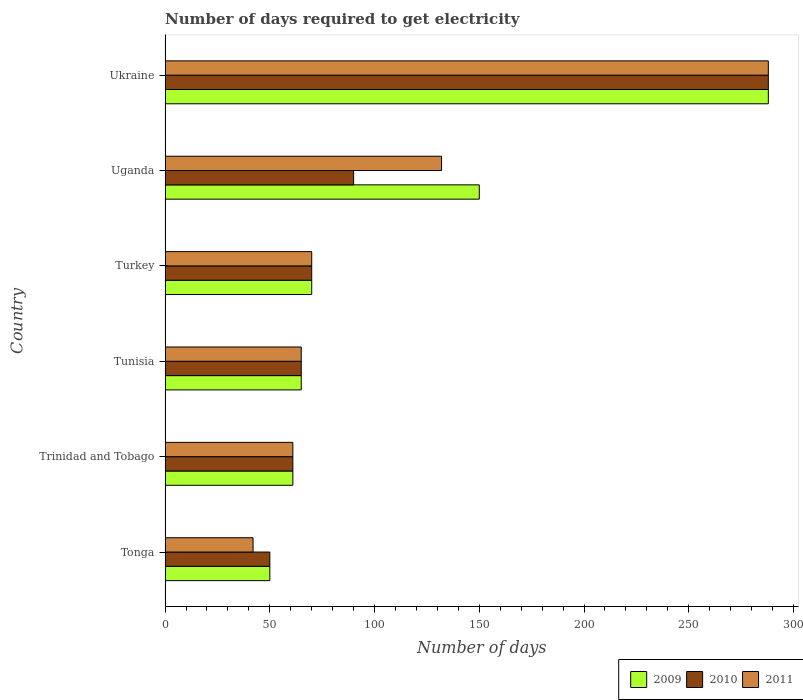How many different coloured bars are there?
Keep it short and to the point. 3. How many groups of bars are there?
Offer a terse response. 6. Are the number of bars per tick equal to the number of legend labels?
Keep it short and to the point. Yes. How many bars are there on the 3rd tick from the bottom?
Ensure brevity in your answer.  3. In how many cases, is the number of bars for a given country not equal to the number of legend labels?
Your answer should be very brief. 0. Across all countries, what is the maximum number of days required to get electricity in in 2010?
Provide a short and direct response. 288. In which country was the number of days required to get electricity in in 2009 maximum?
Offer a very short reply. Ukraine. In which country was the number of days required to get electricity in in 2010 minimum?
Offer a terse response. Tonga. What is the total number of days required to get electricity in in 2011 in the graph?
Offer a very short reply. 658. What is the difference between the number of days required to get electricity in in 2010 in Tonga and that in Trinidad and Tobago?
Your answer should be compact. -11. What is the difference between the number of days required to get electricity in in 2010 in Tunisia and the number of days required to get electricity in in 2011 in Ukraine?
Give a very brief answer. -223. What is the average number of days required to get electricity in in 2011 per country?
Provide a succinct answer. 109.67. What is the difference between the number of days required to get electricity in in 2009 and number of days required to get electricity in in 2010 in Tunisia?
Offer a very short reply. 0. What is the ratio of the number of days required to get electricity in in 2009 in Tunisia to that in Ukraine?
Offer a terse response. 0.23. Is the number of days required to get electricity in in 2011 in Tonga less than that in Trinidad and Tobago?
Offer a very short reply. Yes. Is the difference between the number of days required to get electricity in in 2009 in Trinidad and Tobago and Ukraine greater than the difference between the number of days required to get electricity in in 2010 in Trinidad and Tobago and Ukraine?
Your response must be concise. No. What is the difference between the highest and the second highest number of days required to get electricity in in 2009?
Your response must be concise. 138. What is the difference between the highest and the lowest number of days required to get electricity in in 2009?
Provide a short and direct response. 238. In how many countries, is the number of days required to get electricity in in 2010 greater than the average number of days required to get electricity in in 2010 taken over all countries?
Provide a succinct answer. 1. Is the sum of the number of days required to get electricity in in 2009 in Tonga and Tunisia greater than the maximum number of days required to get electricity in in 2011 across all countries?
Make the answer very short. No. What does the 3rd bar from the bottom in Turkey represents?
Make the answer very short. 2011. Is it the case that in every country, the sum of the number of days required to get electricity in in 2011 and number of days required to get electricity in in 2010 is greater than the number of days required to get electricity in in 2009?
Provide a short and direct response. Yes. What is the difference between two consecutive major ticks on the X-axis?
Offer a very short reply. 50. Does the graph contain grids?
Provide a succinct answer. No. How are the legend labels stacked?
Provide a short and direct response. Horizontal. What is the title of the graph?
Ensure brevity in your answer.  Number of days required to get electricity. Does "2000" appear as one of the legend labels in the graph?
Ensure brevity in your answer.  No. What is the label or title of the X-axis?
Make the answer very short. Number of days. What is the label or title of the Y-axis?
Make the answer very short. Country. What is the Number of days of 2010 in Trinidad and Tobago?
Provide a succinct answer. 61. What is the Number of days of 2009 in Tunisia?
Ensure brevity in your answer.  65. What is the Number of days in 2010 in Tunisia?
Ensure brevity in your answer.  65. What is the Number of days in 2009 in Turkey?
Make the answer very short. 70. What is the Number of days in 2010 in Turkey?
Your response must be concise. 70. What is the Number of days of 2009 in Uganda?
Make the answer very short. 150. What is the Number of days in 2011 in Uganda?
Keep it short and to the point. 132. What is the Number of days of 2009 in Ukraine?
Your answer should be very brief. 288. What is the Number of days in 2010 in Ukraine?
Provide a succinct answer. 288. What is the Number of days in 2011 in Ukraine?
Your answer should be very brief. 288. Across all countries, what is the maximum Number of days in 2009?
Offer a terse response. 288. Across all countries, what is the maximum Number of days of 2010?
Your answer should be very brief. 288. Across all countries, what is the maximum Number of days in 2011?
Your answer should be compact. 288. Across all countries, what is the minimum Number of days of 2010?
Make the answer very short. 50. What is the total Number of days of 2009 in the graph?
Give a very brief answer. 684. What is the total Number of days in 2010 in the graph?
Keep it short and to the point. 624. What is the total Number of days of 2011 in the graph?
Offer a terse response. 658. What is the difference between the Number of days in 2009 in Tonga and that in Trinidad and Tobago?
Offer a terse response. -11. What is the difference between the Number of days of 2009 in Tonga and that in Tunisia?
Offer a very short reply. -15. What is the difference between the Number of days of 2011 in Tonga and that in Tunisia?
Keep it short and to the point. -23. What is the difference between the Number of days in 2010 in Tonga and that in Turkey?
Keep it short and to the point. -20. What is the difference between the Number of days in 2011 in Tonga and that in Turkey?
Your answer should be compact. -28. What is the difference between the Number of days in 2009 in Tonga and that in Uganda?
Provide a short and direct response. -100. What is the difference between the Number of days of 2011 in Tonga and that in Uganda?
Your answer should be compact. -90. What is the difference between the Number of days in 2009 in Tonga and that in Ukraine?
Give a very brief answer. -238. What is the difference between the Number of days of 2010 in Tonga and that in Ukraine?
Make the answer very short. -238. What is the difference between the Number of days of 2011 in Tonga and that in Ukraine?
Keep it short and to the point. -246. What is the difference between the Number of days in 2010 in Trinidad and Tobago and that in Tunisia?
Provide a succinct answer. -4. What is the difference between the Number of days in 2009 in Trinidad and Tobago and that in Turkey?
Give a very brief answer. -9. What is the difference between the Number of days of 2009 in Trinidad and Tobago and that in Uganda?
Your answer should be very brief. -89. What is the difference between the Number of days of 2010 in Trinidad and Tobago and that in Uganda?
Offer a terse response. -29. What is the difference between the Number of days in 2011 in Trinidad and Tobago and that in Uganda?
Your answer should be very brief. -71. What is the difference between the Number of days of 2009 in Trinidad and Tobago and that in Ukraine?
Provide a short and direct response. -227. What is the difference between the Number of days in 2010 in Trinidad and Tobago and that in Ukraine?
Offer a terse response. -227. What is the difference between the Number of days of 2011 in Trinidad and Tobago and that in Ukraine?
Offer a terse response. -227. What is the difference between the Number of days of 2009 in Tunisia and that in Turkey?
Ensure brevity in your answer.  -5. What is the difference between the Number of days in 2010 in Tunisia and that in Turkey?
Provide a succinct answer. -5. What is the difference between the Number of days of 2011 in Tunisia and that in Turkey?
Give a very brief answer. -5. What is the difference between the Number of days in 2009 in Tunisia and that in Uganda?
Ensure brevity in your answer.  -85. What is the difference between the Number of days of 2010 in Tunisia and that in Uganda?
Give a very brief answer. -25. What is the difference between the Number of days of 2011 in Tunisia and that in Uganda?
Make the answer very short. -67. What is the difference between the Number of days of 2009 in Tunisia and that in Ukraine?
Offer a terse response. -223. What is the difference between the Number of days of 2010 in Tunisia and that in Ukraine?
Your answer should be compact. -223. What is the difference between the Number of days in 2011 in Tunisia and that in Ukraine?
Keep it short and to the point. -223. What is the difference between the Number of days in 2009 in Turkey and that in Uganda?
Provide a short and direct response. -80. What is the difference between the Number of days in 2011 in Turkey and that in Uganda?
Offer a very short reply. -62. What is the difference between the Number of days in 2009 in Turkey and that in Ukraine?
Provide a succinct answer. -218. What is the difference between the Number of days of 2010 in Turkey and that in Ukraine?
Your answer should be compact. -218. What is the difference between the Number of days of 2011 in Turkey and that in Ukraine?
Offer a terse response. -218. What is the difference between the Number of days of 2009 in Uganda and that in Ukraine?
Keep it short and to the point. -138. What is the difference between the Number of days of 2010 in Uganda and that in Ukraine?
Give a very brief answer. -198. What is the difference between the Number of days of 2011 in Uganda and that in Ukraine?
Provide a short and direct response. -156. What is the difference between the Number of days in 2009 in Tonga and the Number of days in 2010 in Trinidad and Tobago?
Keep it short and to the point. -11. What is the difference between the Number of days of 2010 in Tonga and the Number of days of 2011 in Trinidad and Tobago?
Provide a succinct answer. -11. What is the difference between the Number of days in 2009 in Tonga and the Number of days in 2011 in Tunisia?
Keep it short and to the point. -15. What is the difference between the Number of days in 2009 in Tonga and the Number of days in 2010 in Uganda?
Your answer should be very brief. -40. What is the difference between the Number of days in 2009 in Tonga and the Number of days in 2011 in Uganda?
Make the answer very short. -82. What is the difference between the Number of days in 2010 in Tonga and the Number of days in 2011 in Uganda?
Keep it short and to the point. -82. What is the difference between the Number of days in 2009 in Tonga and the Number of days in 2010 in Ukraine?
Offer a very short reply. -238. What is the difference between the Number of days of 2009 in Tonga and the Number of days of 2011 in Ukraine?
Give a very brief answer. -238. What is the difference between the Number of days of 2010 in Tonga and the Number of days of 2011 in Ukraine?
Give a very brief answer. -238. What is the difference between the Number of days in 2009 in Trinidad and Tobago and the Number of days in 2010 in Tunisia?
Keep it short and to the point. -4. What is the difference between the Number of days in 2009 in Trinidad and Tobago and the Number of days in 2011 in Tunisia?
Your answer should be very brief. -4. What is the difference between the Number of days of 2009 in Trinidad and Tobago and the Number of days of 2011 in Turkey?
Your answer should be compact. -9. What is the difference between the Number of days in 2010 in Trinidad and Tobago and the Number of days in 2011 in Turkey?
Offer a very short reply. -9. What is the difference between the Number of days of 2009 in Trinidad and Tobago and the Number of days of 2010 in Uganda?
Make the answer very short. -29. What is the difference between the Number of days in 2009 in Trinidad and Tobago and the Number of days in 2011 in Uganda?
Provide a short and direct response. -71. What is the difference between the Number of days in 2010 in Trinidad and Tobago and the Number of days in 2011 in Uganda?
Give a very brief answer. -71. What is the difference between the Number of days in 2009 in Trinidad and Tobago and the Number of days in 2010 in Ukraine?
Your answer should be very brief. -227. What is the difference between the Number of days of 2009 in Trinidad and Tobago and the Number of days of 2011 in Ukraine?
Offer a terse response. -227. What is the difference between the Number of days of 2010 in Trinidad and Tobago and the Number of days of 2011 in Ukraine?
Give a very brief answer. -227. What is the difference between the Number of days of 2009 in Tunisia and the Number of days of 2010 in Turkey?
Give a very brief answer. -5. What is the difference between the Number of days of 2010 in Tunisia and the Number of days of 2011 in Turkey?
Give a very brief answer. -5. What is the difference between the Number of days of 2009 in Tunisia and the Number of days of 2011 in Uganda?
Offer a terse response. -67. What is the difference between the Number of days of 2010 in Tunisia and the Number of days of 2011 in Uganda?
Provide a short and direct response. -67. What is the difference between the Number of days in 2009 in Tunisia and the Number of days in 2010 in Ukraine?
Provide a succinct answer. -223. What is the difference between the Number of days in 2009 in Tunisia and the Number of days in 2011 in Ukraine?
Provide a short and direct response. -223. What is the difference between the Number of days of 2010 in Tunisia and the Number of days of 2011 in Ukraine?
Make the answer very short. -223. What is the difference between the Number of days in 2009 in Turkey and the Number of days in 2010 in Uganda?
Provide a short and direct response. -20. What is the difference between the Number of days of 2009 in Turkey and the Number of days of 2011 in Uganda?
Your answer should be very brief. -62. What is the difference between the Number of days of 2010 in Turkey and the Number of days of 2011 in Uganda?
Offer a very short reply. -62. What is the difference between the Number of days in 2009 in Turkey and the Number of days in 2010 in Ukraine?
Your answer should be very brief. -218. What is the difference between the Number of days of 2009 in Turkey and the Number of days of 2011 in Ukraine?
Make the answer very short. -218. What is the difference between the Number of days of 2010 in Turkey and the Number of days of 2011 in Ukraine?
Keep it short and to the point. -218. What is the difference between the Number of days of 2009 in Uganda and the Number of days of 2010 in Ukraine?
Ensure brevity in your answer.  -138. What is the difference between the Number of days in 2009 in Uganda and the Number of days in 2011 in Ukraine?
Offer a very short reply. -138. What is the difference between the Number of days in 2010 in Uganda and the Number of days in 2011 in Ukraine?
Your response must be concise. -198. What is the average Number of days in 2009 per country?
Make the answer very short. 114. What is the average Number of days of 2010 per country?
Make the answer very short. 104. What is the average Number of days in 2011 per country?
Give a very brief answer. 109.67. What is the difference between the Number of days of 2009 and Number of days of 2010 in Tonga?
Offer a very short reply. 0. What is the difference between the Number of days in 2009 and Number of days in 2011 in Tonga?
Ensure brevity in your answer.  8. What is the difference between the Number of days of 2010 and Number of days of 2011 in Tonga?
Your response must be concise. 8. What is the difference between the Number of days in 2009 and Number of days in 2010 in Trinidad and Tobago?
Offer a very short reply. 0. What is the difference between the Number of days of 2009 and Number of days of 2011 in Trinidad and Tobago?
Your answer should be compact. 0. What is the difference between the Number of days of 2010 and Number of days of 2011 in Trinidad and Tobago?
Your response must be concise. 0. What is the difference between the Number of days of 2009 and Number of days of 2011 in Tunisia?
Your answer should be compact. 0. What is the difference between the Number of days of 2010 and Number of days of 2011 in Tunisia?
Ensure brevity in your answer.  0. What is the difference between the Number of days in 2009 and Number of days in 2011 in Turkey?
Your response must be concise. 0. What is the difference between the Number of days of 2010 and Number of days of 2011 in Turkey?
Ensure brevity in your answer.  0. What is the difference between the Number of days of 2009 and Number of days of 2011 in Uganda?
Your response must be concise. 18. What is the difference between the Number of days of 2010 and Number of days of 2011 in Uganda?
Your answer should be very brief. -42. What is the difference between the Number of days of 2009 and Number of days of 2011 in Ukraine?
Keep it short and to the point. 0. What is the difference between the Number of days of 2010 and Number of days of 2011 in Ukraine?
Give a very brief answer. 0. What is the ratio of the Number of days in 2009 in Tonga to that in Trinidad and Tobago?
Offer a terse response. 0.82. What is the ratio of the Number of days in 2010 in Tonga to that in Trinidad and Tobago?
Ensure brevity in your answer.  0.82. What is the ratio of the Number of days of 2011 in Tonga to that in Trinidad and Tobago?
Offer a terse response. 0.69. What is the ratio of the Number of days in 2009 in Tonga to that in Tunisia?
Provide a succinct answer. 0.77. What is the ratio of the Number of days of 2010 in Tonga to that in Tunisia?
Ensure brevity in your answer.  0.77. What is the ratio of the Number of days in 2011 in Tonga to that in Tunisia?
Provide a succinct answer. 0.65. What is the ratio of the Number of days of 2009 in Tonga to that in Turkey?
Provide a succinct answer. 0.71. What is the ratio of the Number of days in 2010 in Tonga to that in Turkey?
Keep it short and to the point. 0.71. What is the ratio of the Number of days in 2010 in Tonga to that in Uganda?
Provide a succinct answer. 0.56. What is the ratio of the Number of days in 2011 in Tonga to that in Uganda?
Offer a terse response. 0.32. What is the ratio of the Number of days of 2009 in Tonga to that in Ukraine?
Ensure brevity in your answer.  0.17. What is the ratio of the Number of days of 2010 in Tonga to that in Ukraine?
Keep it short and to the point. 0.17. What is the ratio of the Number of days in 2011 in Tonga to that in Ukraine?
Make the answer very short. 0.15. What is the ratio of the Number of days of 2009 in Trinidad and Tobago to that in Tunisia?
Provide a short and direct response. 0.94. What is the ratio of the Number of days of 2010 in Trinidad and Tobago to that in Tunisia?
Ensure brevity in your answer.  0.94. What is the ratio of the Number of days in 2011 in Trinidad and Tobago to that in Tunisia?
Make the answer very short. 0.94. What is the ratio of the Number of days of 2009 in Trinidad and Tobago to that in Turkey?
Offer a very short reply. 0.87. What is the ratio of the Number of days in 2010 in Trinidad and Tobago to that in Turkey?
Give a very brief answer. 0.87. What is the ratio of the Number of days of 2011 in Trinidad and Tobago to that in Turkey?
Offer a terse response. 0.87. What is the ratio of the Number of days of 2009 in Trinidad and Tobago to that in Uganda?
Make the answer very short. 0.41. What is the ratio of the Number of days in 2010 in Trinidad and Tobago to that in Uganda?
Give a very brief answer. 0.68. What is the ratio of the Number of days of 2011 in Trinidad and Tobago to that in Uganda?
Offer a terse response. 0.46. What is the ratio of the Number of days in 2009 in Trinidad and Tobago to that in Ukraine?
Make the answer very short. 0.21. What is the ratio of the Number of days in 2010 in Trinidad and Tobago to that in Ukraine?
Keep it short and to the point. 0.21. What is the ratio of the Number of days of 2011 in Trinidad and Tobago to that in Ukraine?
Make the answer very short. 0.21. What is the ratio of the Number of days of 2011 in Tunisia to that in Turkey?
Offer a very short reply. 0.93. What is the ratio of the Number of days in 2009 in Tunisia to that in Uganda?
Offer a terse response. 0.43. What is the ratio of the Number of days in 2010 in Tunisia to that in Uganda?
Ensure brevity in your answer.  0.72. What is the ratio of the Number of days of 2011 in Tunisia to that in Uganda?
Give a very brief answer. 0.49. What is the ratio of the Number of days of 2009 in Tunisia to that in Ukraine?
Offer a terse response. 0.23. What is the ratio of the Number of days of 2010 in Tunisia to that in Ukraine?
Make the answer very short. 0.23. What is the ratio of the Number of days in 2011 in Tunisia to that in Ukraine?
Ensure brevity in your answer.  0.23. What is the ratio of the Number of days in 2009 in Turkey to that in Uganda?
Make the answer very short. 0.47. What is the ratio of the Number of days in 2010 in Turkey to that in Uganda?
Ensure brevity in your answer.  0.78. What is the ratio of the Number of days in 2011 in Turkey to that in Uganda?
Provide a short and direct response. 0.53. What is the ratio of the Number of days of 2009 in Turkey to that in Ukraine?
Make the answer very short. 0.24. What is the ratio of the Number of days in 2010 in Turkey to that in Ukraine?
Your answer should be very brief. 0.24. What is the ratio of the Number of days of 2011 in Turkey to that in Ukraine?
Give a very brief answer. 0.24. What is the ratio of the Number of days in 2009 in Uganda to that in Ukraine?
Ensure brevity in your answer.  0.52. What is the ratio of the Number of days in 2010 in Uganda to that in Ukraine?
Offer a terse response. 0.31. What is the ratio of the Number of days of 2011 in Uganda to that in Ukraine?
Your answer should be very brief. 0.46. What is the difference between the highest and the second highest Number of days of 2009?
Offer a very short reply. 138. What is the difference between the highest and the second highest Number of days of 2010?
Provide a short and direct response. 198. What is the difference between the highest and the second highest Number of days of 2011?
Your answer should be very brief. 156. What is the difference between the highest and the lowest Number of days in 2009?
Make the answer very short. 238. What is the difference between the highest and the lowest Number of days in 2010?
Keep it short and to the point. 238. What is the difference between the highest and the lowest Number of days in 2011?
Make the answer very short. 246. 